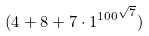Convert formula to latex. <formula><loc_0><loc_0><loc_500><loc_500>( 4 + 8 + 7 \cdot { 1 ^ { 1 0 0 } } ^ { \sqrt { 7 } } )</formula> 